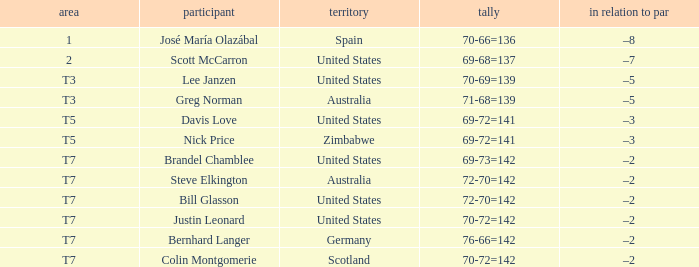Name the Player who has a Country of united states, and a To par of –5? Lee Janzen. 